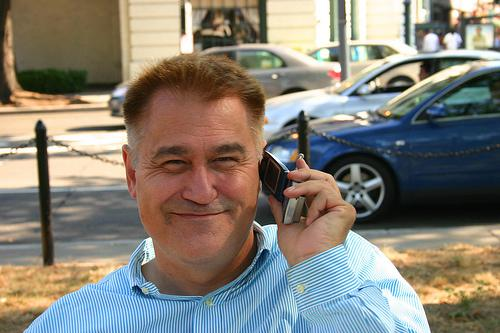Question: where was this photo taken?
Choices:
A. In a hall.
B. In an aisle.
C. In a parking lot.
D. In the back of a truck.
Answer with the letter. Answer: C Question: why is he smiling?
Choices:
A. He is sad.
B. He is surprised.
C. He is happy.
D. He is anxious.
Answer with the letter. Answer: C Question: what is he doing?
Choices:
A. Using a computer.
B. Using a tablet.
C. Using a phone.
D. Using a pager.
Answer with the letter. Answer: C Question: what else is visible?
Choices:
A. Motorcycles.
B. Bikes.
C. Cars.
D. Scooters.
Answer with the letter. Answer: C Question: who is he?
Choices:
A. A man.
B. A boy.
C. A baby.
D. A woman.
Answer with the letter. Answer: A 